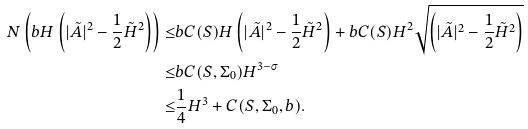<formula> <loc_0><loc_0><loc_500><loc_500>N \left ( b H \left ( | \tilde { A } | ^ { 2 } - \frac { 1 } { 2 } \tilde { H } ^ { 2 } \right ) \right ) \leq & b C ( S ) H \left ( | \tilde { A } | ^ { 2 } - \frac { 1 } { 2 } \tilde { H } ^ { 2 } \right ) + b C ( S ) H ^ { 2 } \sqrt { \left ( | \tilde { A } | ^ { 2 } - \frac { 1 } { 2 } \tilde { H } ^ { 2 } \right ) } \\ \leq & b C ( S , \Sigma _ { 0 } ) H ^ { 3 - \sigma } \\ \leq & \frac { 1 } { 4 } H ^ { 3 } + C ( S , \Sigma _ { 0 } , b ) .</formula> 